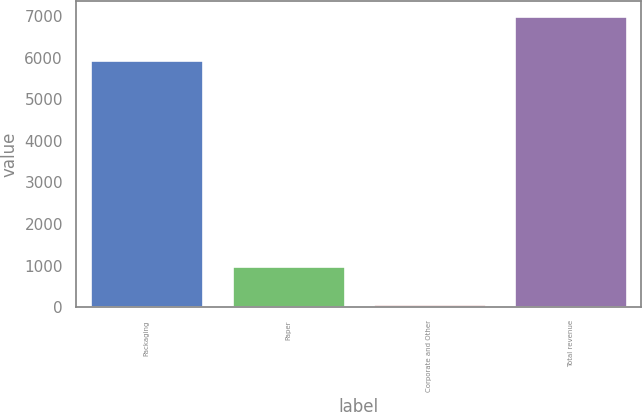<chart> <loc_0><loc_0><loc_500><loc_500><bar_chart><fcel>Packaging<fcel>Paper<fcel>Corporate and Other<fcel>Total revenue<nl><fcel>5938.5<fcel>1002<fcel>74.1<fcel>7014.6<nl></chart> 